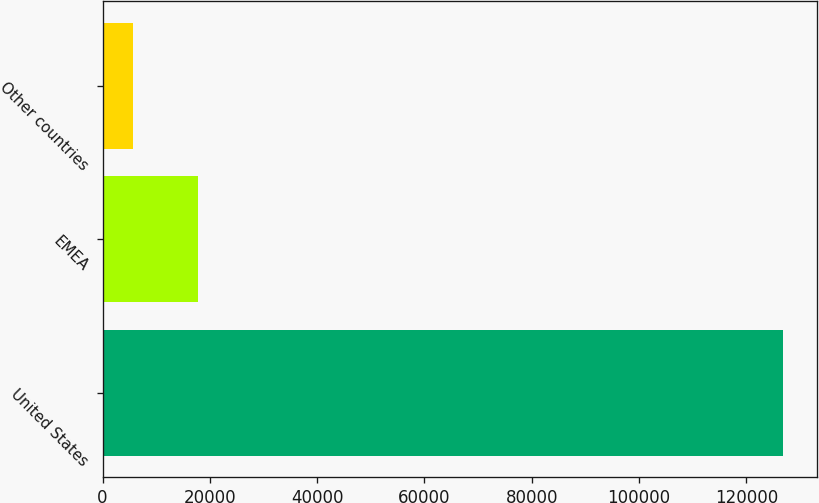Convert chart to OTSL. <chart><loc_0><loc_0><loc_500><loc_500><bar_chart><fcel>United States<fcel>EMEA<fcel>Other countries<nl><fcel>126790<fcel>17821.6<fcel>5714<nl></chart> 